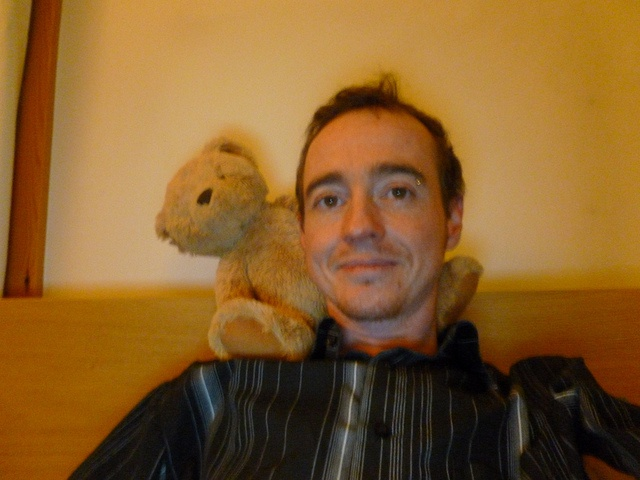Describe the objects in this image and their specific colors. I can see people in orange, black, brown, and maroon tones and teddy bear in orange, olive, and maroon tones in this image. 